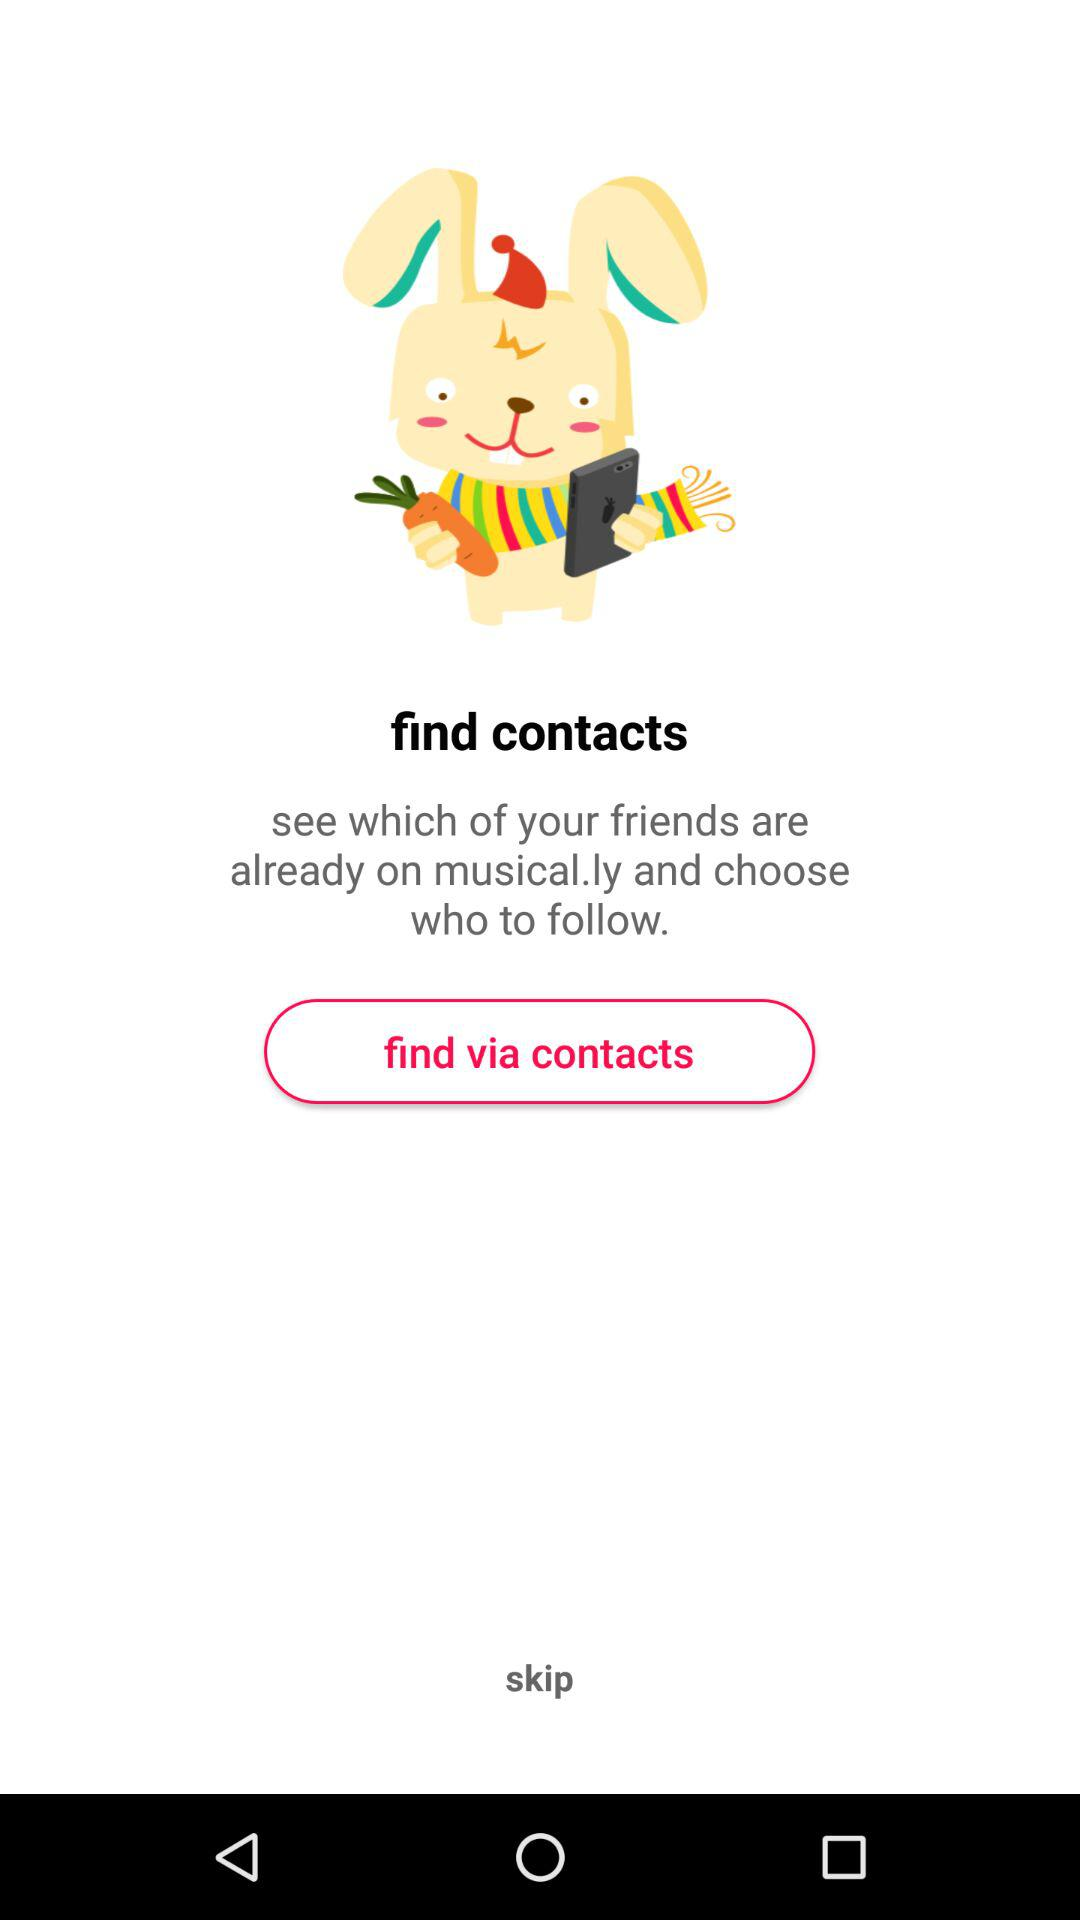What is the name of the application? The name of the application is "musical.ly". 